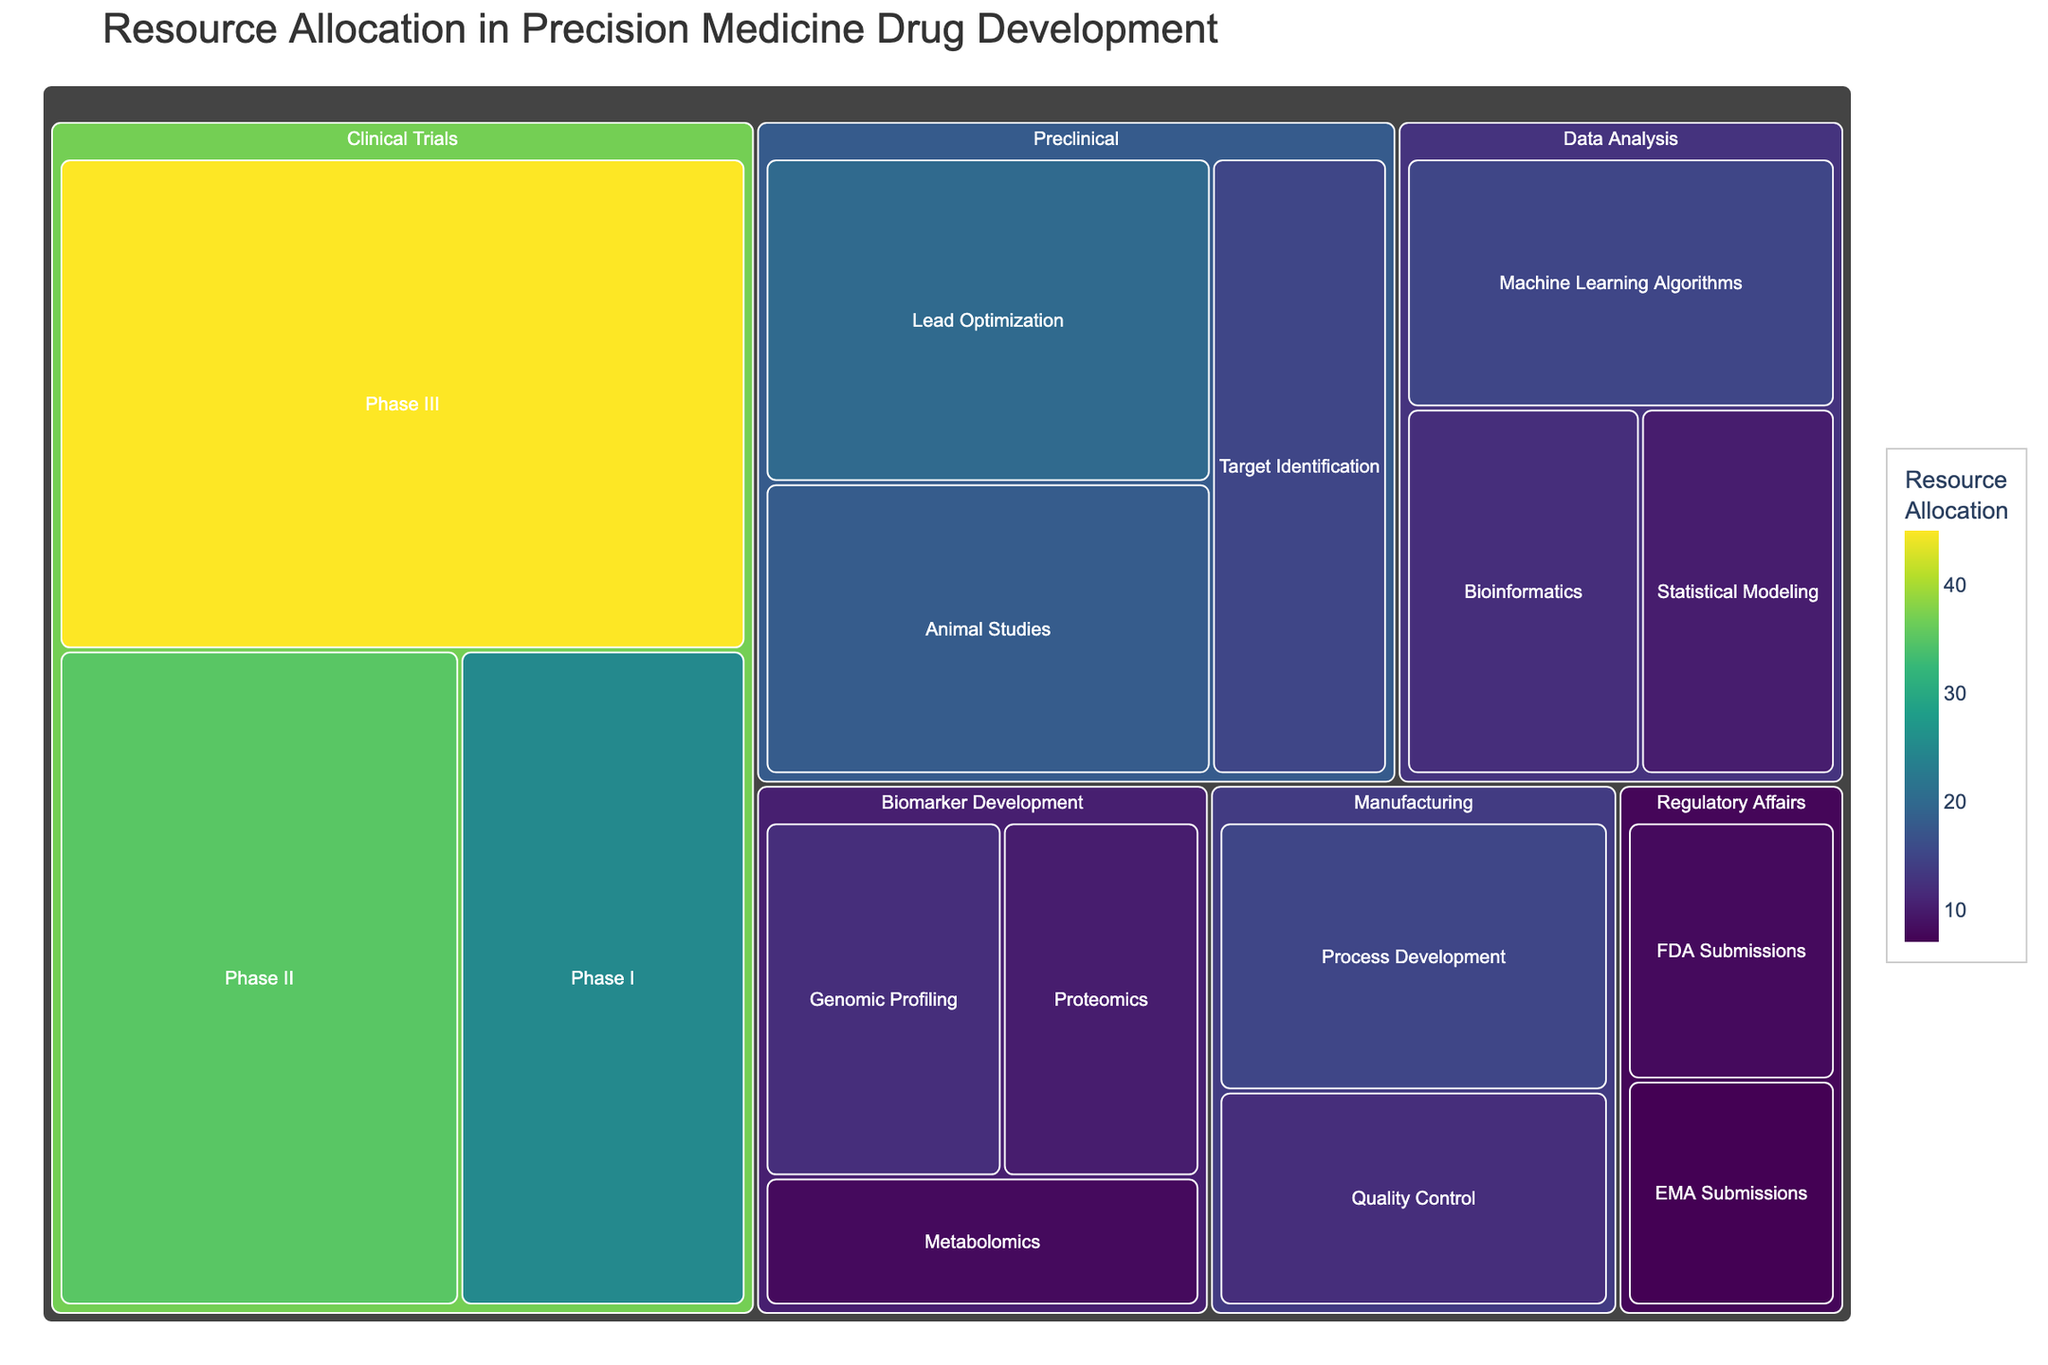what is the largest resource allocation in the Clinical Trials stage? The Clinical Trials stage in the treemap consists of Phase I, Phase II, and Phase III. Comparing the allocated values, we find that the largest allocation in Clinical Trials is in Phase III with 45.
Answer: 45 How much total resources are allocated to Preclinical activities? Summing the values allocated to Preclinical activities (Target Identification, Lead Optimization, and Animal Studies) gives us 15 + 20 + 18 = 53.
Answer: 53 Which subcategory in Data Analysis receives the most resources? Within the Data Analysis category, the subcategories are Machine Learning Algorithms, Bioinformatics, and Statistical Modeling, with values of 15, 12, and 10, respectively. The subcategory with the most resources is Machine Learning Algorithms.
Answer: Machine Learning Algorithms How much more is allocated to Clinical Trials: Phase II compared to Preclinical: Animal Studies? Phase II in Clinical Trials has an allocation of 35, while Animal Studies in Preclinical has an allocation of 18. The difference is 35 - 18 = 17.
Answer: 17 Is the resource allocation for Manufacturing greater or less than the allocation for Data Analysis? Summing the values for Manufacturing (Process Development and Quality Control) gives 15 + 12 = 27. Summing the values for Data Analysis (Machine Learning Algorithms, Bioinformatics, and Statistical Modeling) gives 15 + 12 + 10 = 37. Therefore, allocation for Manufacturing is less than Data Analysis.
Answer: Less What are the three subcategories within Biomarker Development, and their respective resource allocations? The Biomarker Development category has three subcategories: Genomic Profiling (12), Proteomics (10), and Metabolomics (8).
Answer: Genomic Profiling: 12, Proteomics: 10, Metabolomics: 8 How does the resource allocation for Regulatory Affairs: FDA Submissions compare to EMA Submissions? Examining the values, FDA Submissions has 8, and EMA Submissions has 7. Hence, FDA Submissions has a slightly higher allocation than EMA Submissions.
Answer: FDA Submissions has more What is the sum of allocations for Biomarker Development and Regulatory Affairs combined? Summing the values for Biomarker Development (12 + 10 + 8) gives 30, and the values for Regulatory Affairs (8 + 7) give 15. So, the combined allocation is 30 + 15 = 45.
Answer: 45 Which stage in drug development has the highest overall resource allocation? By summing the values for each stage: Preclinical (15 + 20 + 18 = 53), Clinical Trials (25 + 35 + 45 = 105), Biomarker Development (12 + 10 + 8 = 30), Data Analysis (15 + 12 + 10 = 37), Regulatory Affairs (8 + 7 = 15), and Manufacturing (15 + 12 = 27), we find the Clinical Trials stage has the highest overall allocation.
Answer: Clinical Trials Between Metabolomics and Quality Control, which receives fewer resources, and by how much? Metabolomics has an allocation of 8, and Quality Control has 12. The difference is 12 - 8 = 4. Therefore, Metabolomics receives fewer resources by 4.
Answer: Metabolomics by 4 